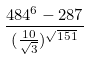<formula> <loc_0><loc_0><loc_500><loc_500>\frac { 4 8 4 ^ { 6 } - 2 8 7 } { ( \frac { 1 0 } { \sqrt { 3 } } ) ^ { \sqrt { 1 5 1 } } }</formula> 